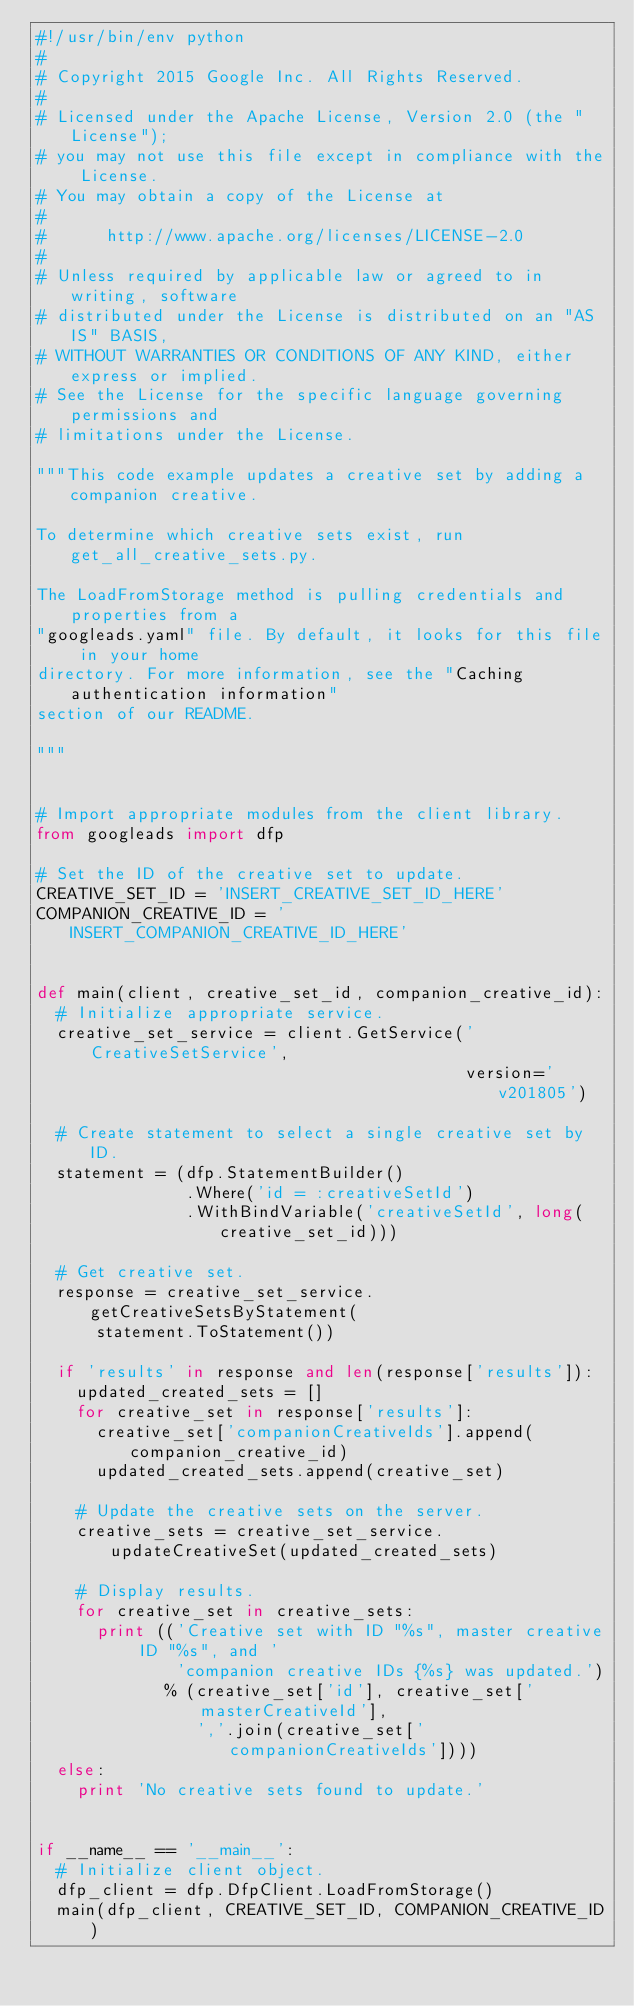Convert code to text. <code><loc_0><loc_0><loc_500><loc_500><_Python_>#!/usr/bin/env python
#
# Copyright 2015 Google Inc. All Rights Reserved.
#
# Licensed under the Apache License, Version 2.0 (the "License");
# you may not use this file except in compliance with the License.
# You may obtain a copy of the License at
#
#      http://www.apache.org/licenses/LICENSE-2.0
#
# Unless required by applicable law or agreed to in writing, software
# distributed under the License is distributed on an "AS IS" BASIS,
# WITHOUT WARRANTIES OR CONDITIONS OF ANY KIND, either express or implied.
# See the License for the specific language governing permissions and
# limitations under the License.

"""This code example updates a creative set by adding a companion creative.

To determine which creative sets exist, run get_all_creative_sets.py.

The LoadFromStorage method is pulling credentials and properties from a
"googleads.yaml" file. By default, it looks for this file in your home
directory. For more information, see the "Caching authentication information"
section of our README.

"""


# Import appropriate modules from the client library.
from googleads import dfp

# Set the ID of the creative set to update.
CREATIVE_SET_ID = 'INSERT_CREATIVE_SET_ID_HERE'
COMPANION_CREATIVE_ID = 'INSERT_COMPANION_CREATIVE_ID_HERE'


def main(client, creative_set_id, companion_creative_id):
  # Initialize appropriate service.
  creative_set_service = client.GetService('CreativeSetService',
                                           version='v201805')

  # Create statement to select a single creative set by ID.
  statement = (dfp.StatementBuilder()
               .Where('id = :creativeSetId')
               .WithBindVariable('creativeSetId', long(creative_set_id)))

  # Get creative set.
  response = creative_set_service.getCreativeSetsByStatement(
      statement.ToStatement())

  if 'results' in response and len(response['results']):
    updated_created_sets = []
    for creative_set in response['results']:
      creative_set['companionCreativeIds'].append(companion_creative_id)
      updated_created_sets.append(creative_set)

    # Update the creative sets on the server.
    creative_sets = creative_set_service.updateCreativeSet(updated_created_sets)

    # Display results.
    for creative_set in creative_sets:
      print (('Creative set with ID "%s", master creative ID "%s", and '
              'companion creative IDs {%s} was updated.')
             % (creative_set['id'], creative_set['masterCreativeId'],
                ','.join(creative_set['companionCreativeIds'])))
  else:
    print 'No creative sets found to update.'


if __name__ == '__main__':
  # Initialize client object.
  dfp_client = dfp.DfpClient.LoadFromStorage()
  main(dfp_client, CREATIVE_SET_ID, COMPANION_CREATIVE_ID)
</code> 